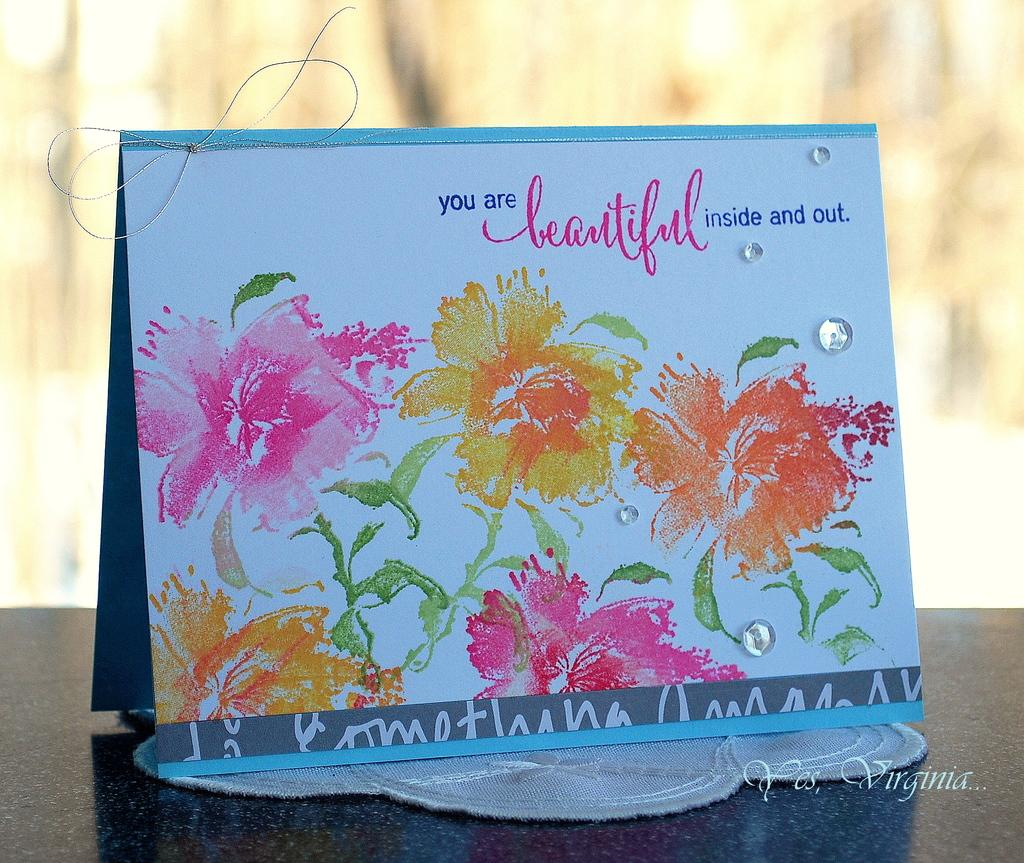What is the main subject in the center of the image? There is a greeting card in the center of the image. Where is the greeting card located? The greeting card is placed on a table. What type of organization is responsible for the design of the greeting card in the image? There is no information about the organization responsible for the design of the greeting card in the image. What is the coefficient of friction between the greeting card and the table in the image? The coefficient of friction cannot be determined from the image. 